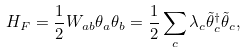Convert formula to latex. <formula><loc_0><loc_0><loc_500><loc_500>H _ { F } = \frac { 1 } { 2 } W _ { a b } \theta _ { a } \theta _ { b } = \frac { 1 } { 2 } \sum _ { c } \lambda _ { c } \tilde { \theta } _ { c } ^ { \dagger } \tilde { \theta } _ { c } ,</formula> 